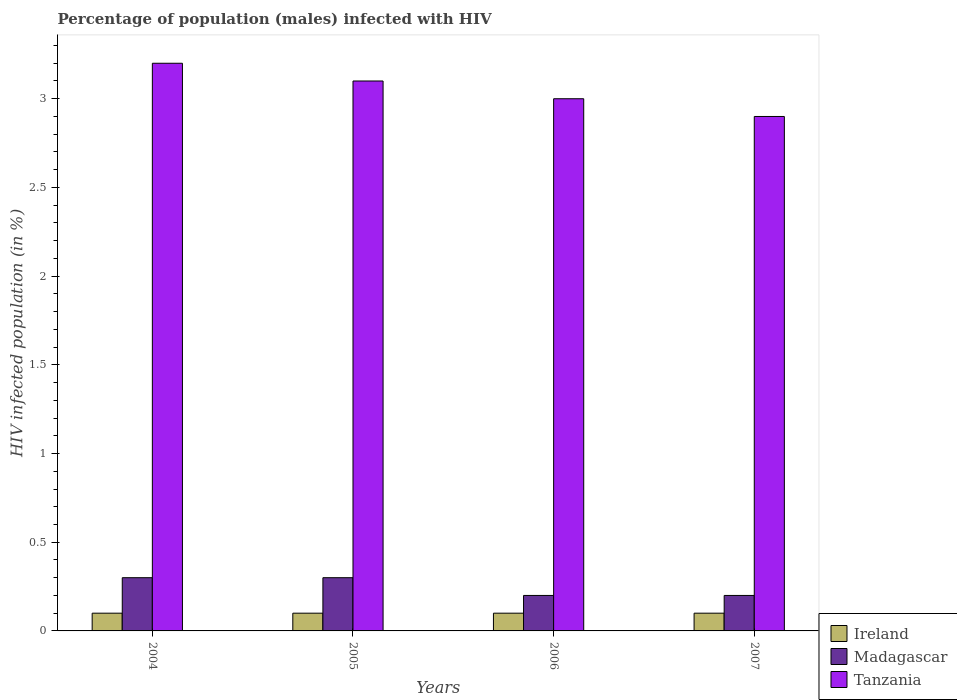How many groups of bars are there?
Offer a very short reply. 4. Are the number of bars per tick equal to the number of legend labels?
Your response must be concise. Yes. Are the number of bars on each tick of the X-axis equal?
Your response must be concise. Yes. How many bars are there on the 3rd tick from the right?
Provide a succinct answer. 3. In how many cases, is the number of bars for a given year not equal to the number of legend labels?
Keep it short and to the point. 0. What is the percentage of HIV infected male population in Tanzania in 2007?
Your response must be concise. 2.9. In which year was the percentage of HIV infected male population in Tanzania maximum?
Ensure brevity in your answer.  2004. In which year was the percentage of HIV infected male population in Tanzania minimum?
Provide a succinct answer. 2007. What is the total percentage of HIV infected male population in Ireland in the graph?
Offer a terse response. 0.4. What is the difference between the percentage of HIV infected male population in Tanzania in 2004 and that in 2005?
Offer a terse response. 0.1. What is the average percentage of HIV infected male population in Tanzania per year?
Provide a short and direct response. 3.05. In the year 2006, what is the difference between the percentage of HIV infected male population in Madagascar and percentage of HIV infected male population in Tanzania?
Provide a succinct answer. -2.8. What is the ratio of the percentage of HIV infected male population in Tanzania in 2005 to that in 2007?
Offer a terse response. 1.07. Is the percentage of HIV infected male population in Tanzania in 2005 less than that in 2006?
Offer a terse response. No. What is the difference between the highest and the second highest percentage of HIV infected male population in Tanzania?
Provide a short and direct response. 0.1. What is the difference between the highest and the lowest percentage of HIV infected male population in Tanzania?
Offer a very short reply. 0.3. In how many years, is the percentage of HIV infected male population in Ireland greater than the average percentage of HIV infected male population in Ireland taken over all years?
Make the answer very short. 0. Is the sum of the percentage of HIV infected male population in Tanzania in 2005 and 2006 greater than the maximum percentage of HIV infected male population in Ireland across all years?
Make the answer very short. Yes. What does the 2nd bar from the left in 2006 represents?
Your answer should be very brief. Madagascar. What does the 3rd bar from the right in 2006 represents?
Give a very brief answer. Ireland. Is it the case that in every year, the sum of the percentage of HIV infected male population in Tanzania and percentage of HIV infected male population in Madagascar is greater than the percentage of HIV infected male population in Ireland?
Your response must be concise. Yes. What is the difference between two consecutive major ticks on the Y-axis?
Offer a terse response. 0.5. Does the graph contain any zero values?
Your response must be concise. No. Does the graph contain grids?
Provide a succinct answer. No. Where does the legend appear in the graph?
Your answer should be compact. Bottom right. How many legend labels are there?
Your response must be concise. 3. How are the legend labels stacked?
Give a very brief answer. Vertical. What is the title of the graph?
Your response must be concise. Percentage of population (males) infected with HIV. Does "Korea (Republic)" appear as one of the legend labels in the graph?
Offer a terse response. No. What is the label or title of the Y-axis?
Give a very brief answer. HIV infected population (in %). What is the HIV infected population (in %) of Madagascar in 2004?
Make the answer very short. 0.3. What is the HIV infected population (in %) in Ireland in 2006?
Provide a short and direct response. 0.1. What is the HIV infected population (in %) in Madagascar in 2006?
Keep it short and to the point. 0.2. What is the HIV infected population (in %) of Ireland in 2007?
Provide a short and direct response. 0.1. What is the HIV infected population (in %) in Tanzania in 2007?
Provide a succinct answer. 2.9. Across all years, what is the maximum HIV infected population (in %) in Madagascar?
Provide a short and direct response. 0.3. Across all years, what is the maximum HIV infected population (in %) in Tanzania?
Give a very brief answer. 3.2. Across all years, what is the minimum HIV infected population (in %) in Madagascar?
Your answer should be very brief. 0.2. What is the total HIV infected population (in %) of Ireland in the graph?
Provide a succinct answer. 0.4. What is the total HIV infected population (in %) in Madagascar in the graph?
Give a very brief answer. 1. What is the difference between the HIV infected population (in %) in Madagascar in 2004 and that in 2006?
Give a very brief answer. 0.1. What is the difference between the HIV infected population (in %) in Tanzania in 2004 and that in 2006?
Ensure brevity in your answer.  0.2. What is the difference between the HIV infected population (in %) of Ireland in 2004 and that in 2007?
Make the answer very short. 0. What is the difference between the HIV infected population (in %) of Madagascar in 2004 and that in 2007?
Your response must be concise. 0.1. What is the difference between the HIV infected population (in %) of Ireland in 2005 and that in 2006?
Give a very brief answer. 0. What is the difference between the HIV infected population (in %) of Ireland in 2005 and that in 2007?
Provide a succinct answer. 0. What is the difference between the HIV infected population (in %) in Madagascar in 2005 and that in 2007?
Your answer should be compact. 0.1. What is the difference between the HIV infected population (in %) of Ireland in 2006 and that in 2007?
Your answer should be very brief. 0. What is the difference between the HIV infected population (in %) of Tanzania in 2006 and that in 2007?
Your answer should be compact. 0.1. What is the difference between the HIV infected population (in %) of Madagascar in 2004 and the HIV infected population (in %) of Tanzania in 2005?
Keep it short and to the point. -2.8. What is the difference between the HIV infected population (in %) of Ireland in 2004 and the HIV infected population (in %) of Madagascar in 2006?
Offer a very short reply. -0.1. What is the difference between the HIV infected population (in %) of Ireland in 2004 and the HIV infected population (in %) of Tanzania in 2006?
Provide a short and direct response. -2.9. What is the difference between the HIV infected population (in %) in Madagascar in 2004 and the HIV infected population (in %) in Tanzania in 2007?
Your response must be concise. -2.6. What is the difference between the HIV infected population (in %) of Madagascar in 2005 and the HIV infected population (in %) of Tanzania in 2006?
Offer a terse response. -2.7. What is the difference between the HIV infected population (in %) in Ireland in 2005 and the HIV infected population (in %) in Madagascar in 2007?
Provide a short and direct response. -0.1. What is the difference between the HIV infected population (in %) of Ireland in 2005 and the HIV infected population (in %) of Tanzania in 2007?
Provide a short and direct response. -2.8. What is the difference between the HIV infected population (in %) of Ireland in 2006 and the HIV infected population (in %) of Madagascar in 2007?
Provide a succinct answer. -0.1. What is the difference between the HIV infected population (in %) of Madagascar in 2006 and the HIV infected population (in %) of Tanzania in 2007?
Make the answer very short. -2.7. What is the average HIV infected population (in %) in Ireland per year?
Offer a terse response. 0.1. What is the average HIV infected population (in %) of Madagascar per year?
Offer a very short reply. 0.25. What is the average HIV infected population (in %) of Tanzania per year?
Offer a terse response. 3.05. In the year 2004, what is the difference between the HIV infected population (in %) of Madagascar and HIV infected population (in %) of Tanzania?
Give a very brief answer. -2.9. In the year 2005, what is the difference between the HIV infected population (in %) in Ireland and HIV infected population (in %) in Tanzania?
Offer a very short reply. -3. In the year 2006, what is the difference between the HIV infected population (in %) of Ireland and HIV infected population (in %) of Tanzania?
Ensure brevity in your answer.  -2.9. In the year 2007, what is the difference between the HIV infected population (in %) of Ireland and HIV infected population (in %) of Madagascar?
Give a very brief answer. -0.1. In the year 2007, what is the difference between the HIV infected population (in %) in Ireland and HIV infected population (in %) in Tanzania?
Provide a succinct answer. -2.8. In the year 2007, what is the difference between the HIV infected population (in %) of Madagascar and HIV infected population (in %) of Tanzania?
Your answer should be very brief. -2.7. What is the ratio of the HIV infected population (in %) in Ireland in 2004 to that in 2005?
Ensure brevity in your answer.  1. What is the ratio of the HIV infected population (in %) of Tanzania in 2004 to that in 2005?
Ensure brevity in your answer.  1.03. What is the ratio of the HIV infected population (in %) of Tanzania in 2004 to that in 2006?
Ensure brevity in your answer.  1.07. What is the ratio of the HIV infected population (in %) in Tanzania in 2004 to that in 2007?
Offer a terse response. 1.1. What is the ratio of the HIV infected population (in %) of Ireland in 2005 to that in 2006?
Provide a succinct answer. 1. What is the ratio of the HIV infected population (in %) in Madagascar in 2005 to that in 2006?
Ensure brevity in your answer.  1.5. What is the ratio of the HIV infected population (in %) of Tanzania in 2005 to that in 2006?
Offer a terse response. 1.03. What is the ratio of the HIV infected population (in %) of Ireland in 2005 to that in 2007?
Your answer should be very brief. 1. What is the ratio of the HIV infected population (in %) in Tanzania in 2005 to that in 2007?
Offer a very short reply. 1.07. What is the ratio of the HIV infected population (in %) in Ireland in 2006 to that in 2007?
Provide a succinct answer. 1. What is the ratio of the HIV infected population (in %) in Tanzania in 2006 to that in 2007?
Offer a very short reply. 1.03. 